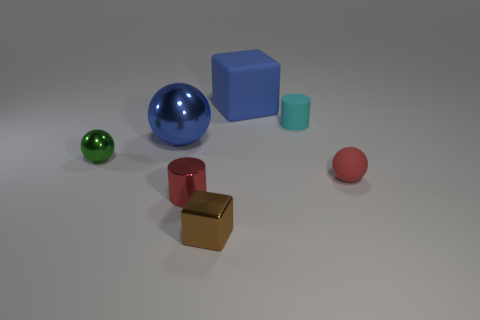Subtract all red balls. Subtract all yellow cylinders. How many balls are left? 2 Add 3 small matte cylinders. How many objects exist? 10 Subtract all cylinders. How many objects are left? 5 Subtract all red blocks. Subtract all cyan objects. How many objects are left? 6 Add 7 metallic cylinders. How many metallic cylinders are left? 8 Add 4 shiny objects. How many shiny objects exist? 8 Subtract 0 red cubes. How many objects are left? 7 